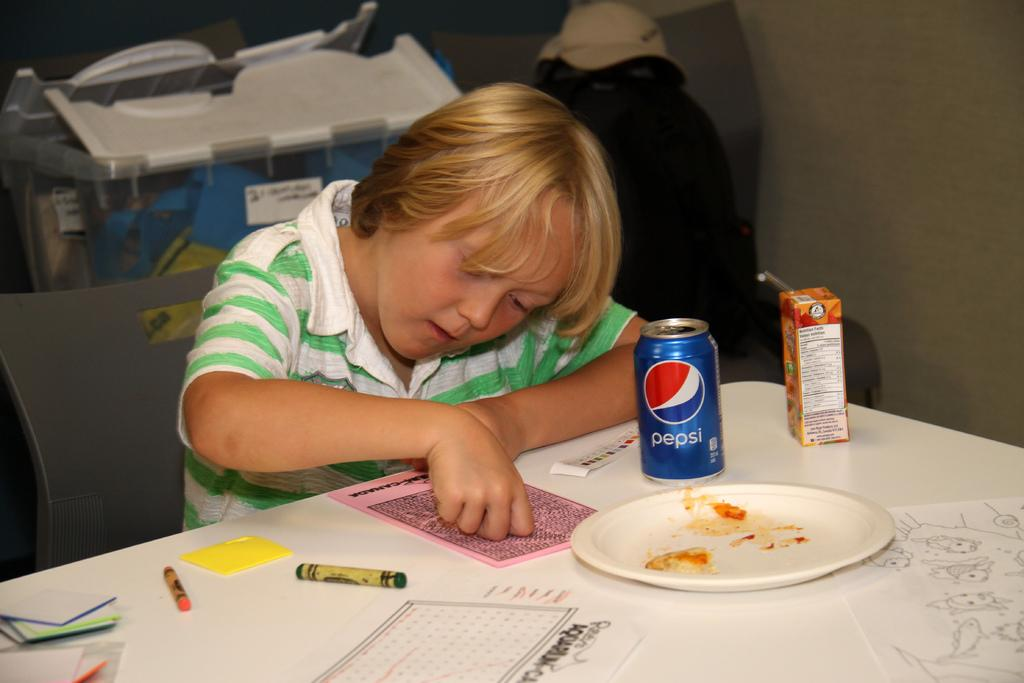<image>
Summarize the visual content of the image. A child sits reading with a can of Pepsi in front of him. 